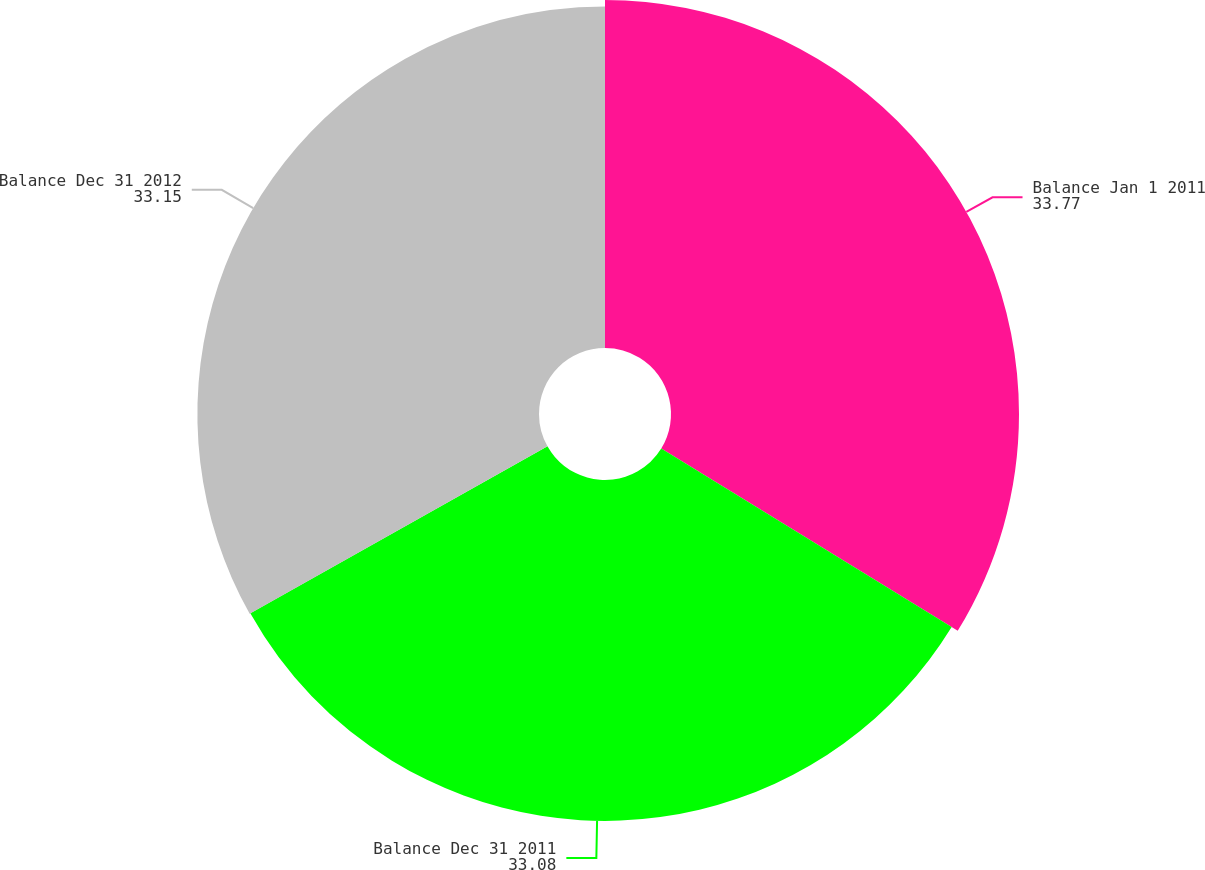Convert chart. <chart><loc_0><loc_0><loc_500><loc_500><pie_chart><fcel>Balance Jan 1 2011<fcel>Balance Dec 31 2011<fcel>Balance Dec 31 2012<nl><fcel>33.77%<fcel>33.08%<fcel>33.15%<nl></chart> 